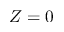Convert formula to latex. <formula><loc_0><loc_0><loc_500><loc_500>Z = 0</formula> 